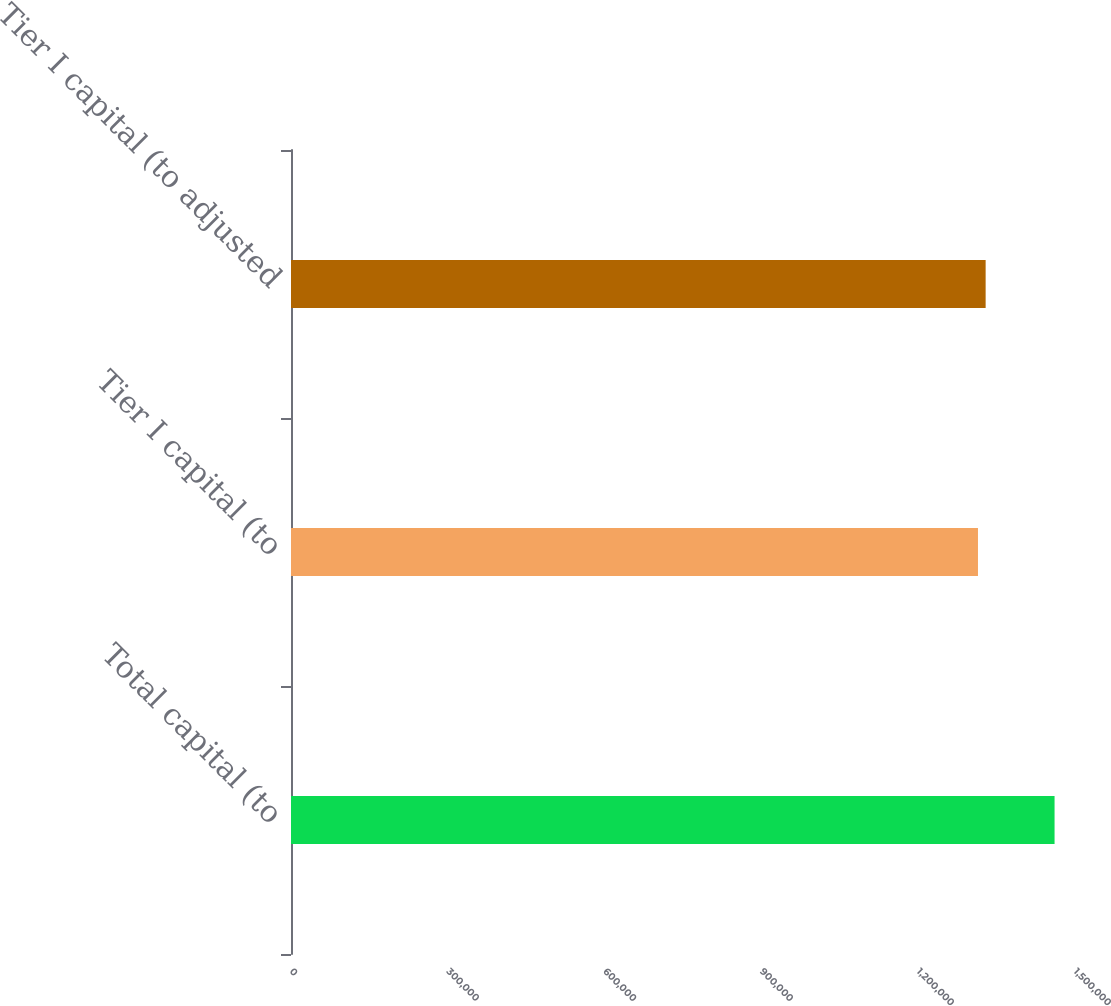<chart> <loc_0><loc_0><loc_500><loc_500><bar_chart><fcel>Total capital (to<fcel>Tier I capital (to<fcel>Tier I capital (to adjusted<nl><fcel>1.4609e+06<fcel>1.31437e+06<fcel>1.32903e+06<nl></chart> 